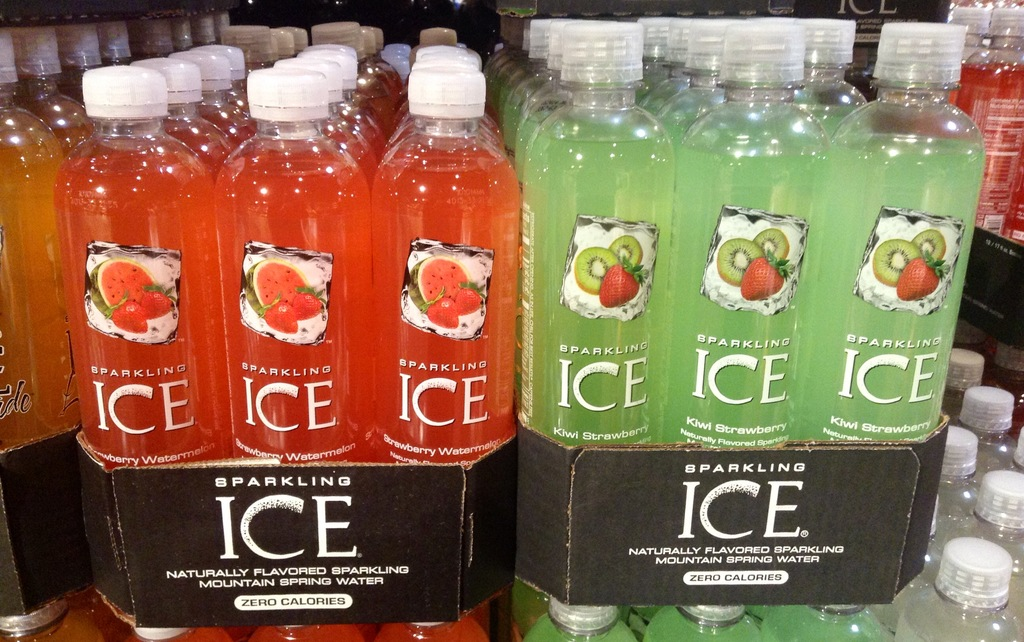What are some of the flavors shown in the Sparkling Ice bottles in the image? The image displays Sparkling Ice bottles in Strawberry Watermelon and Kiwi Strawberry flavors. What makes these beverages appealing to health-conscious consumers? These beverages are appealing due to their zero calorie content and natural flavoring, offering a tasty yet healthy alternative to sugary drinks. 